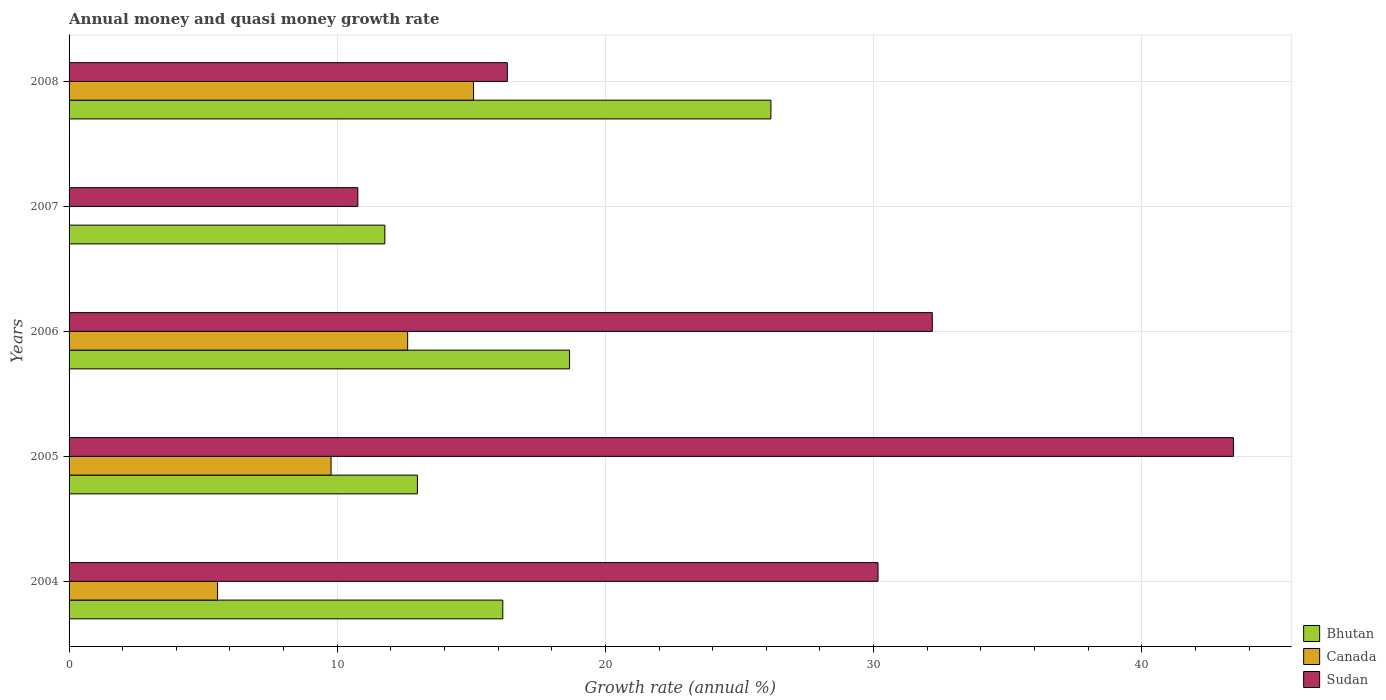How many different coloured bars are there?
Your response must be concise. 3. How many groups of bars are there?
Your answer should be compact. 5. Are the number of bars on each tick of the Y-axis equal?
Provide a succinct answer. No. How many bars are there on the 3rd tick from the top?
Ensure brevity in your answer.  3. In how many cases, is the number of bars for a given year not equal to the number of legend labels?
Your answer should be compact. 1. What is the growth rate in Canada in 2005?
Your answer should be very brief. 9.77. Across all years, what is the maximum growth rate in Sudan?
Your response must be concise. 43.42. Across all years, what is the minimum growth rate in Bhutan?
Your response must be concise. 11.78. What is the total growth rate in Bhutan in the graph?
Provide a short and direct response. 85.77. What is the difference between the growth rate in Bhutan in 2004 and that in 2007?
Provide a short and direct response. 4.4. What is the difference between the growth rate in Bhutan in 2006 and the growth rate in Canada in 2008?
Provide a short and direct response. 3.58. What is the average growth rate in Bhutan per year?
Your answer should be very brief. 17.15. In the year 2004, what is the difference between the growth rate in Sudan and growth rate in Bhutan?
Ensure brevity in your answer.  13.99. In how many years, is the growth rate in Bhutan greater than 32 %?
Keep it short and to the point. 0. What is the ratio of the growth rate in Sudan in 2004 to that in 2008?
Provide a short and direct response. 1.85. Is the growth rate in Sudan in 2005 less than that in 2006?
Provide a succinct answer. No. What is the difference between the highest and the second highest growth rate in Sudan?
Give a very brief answer. 11.23. What is the difference between the highest and the lowest growth rate in Bhutan?
Offer a very short reply. 14.4. In how many years, is the growth rate in Bhutan greater than the average growth rate in Bhutan taken over all years?
Offer a very short reply. 2. Is the sum of the growth rate in Canada in 2004 and 2008 greater than the maximum growth rate in Sudan across all years?
Give a very brief answer. No. Is it the case that in every year, the sum of the growth rate in Sudan and growth rate in Bhutan is greater than the growth rate in Canada?
Make the answer very short. Yes. Are all the bars in the graph horizontal?
Ensure brevity in your answer.  Yes. What is the difference between two consecutive major ticks on the X-axis?
Offer a very short reply. 10. Are the values on the major ticks of X-axis written in scientific E-notation?
Ensure brevity in your answer.  No. How many legend labels are there?
Give a very brief answer. 3. What is the title of the graph?
Your answer should be compact. Annual money and quasi money growth rate. Does "Iraq" appear as one of the legend labels in the graph?
Your answer should be very brief. No. What is the label or title of the X-axis?
Your answer should be compact. Growth rate (annual %). What is the Growth rate (annual %) in Bhutan in 2004?
Your answer should be compact. 16.17. What is the Growth rate (annual %) of Canada in 2004?
Offer a terse response. 5.54. What is the Growth rate (annual %) in Sudan in 2004?
Your answer should be very brief. 30.17. What is the Growth rate (annual %) in Bhutan in 2005?
Provide a short and direct response. 12.99. What is the Growth rate (annual %) in Canada in 2005?
Provide a succinct answer. 9.77. What is the Growth rate (annual %) of Sudan in 2005?
Keep it short and to the point. 43.42. What is the Growth rate (annual %) in Bhutan in 2006?
Offer a terse response. 18.66. What is the Growth rate (annual %) in Canada in 2006?
Provide a short and direct response. 12.63. What is the Growth rate (annual %) in Sudan in 2006?
Give a very brief answer. 32.19. What is the Growth rate (annual %) of Bhutan in 2007?
Your answer should be very brief. 11.78. What is the Growth rate (annual %) in Canada in 2007?
Your answer should be compact. 0. What is the Growth rate (annual %) in Sudan in 2007?
Your answer should be compact. 10.77. What is the Growth rate (annual %) of Bhutan in 2008?
Offer a very short reply. 26.17. What is the Growth rate (annual %) in Canada in 2008?
Ensure brevity in your answer.  15.08. What is the Growth rate (annual %) of Sudan in 2008?
Your answer should be very brief. 16.34. Across all years, what is the maximum Growth rate (annual %) of Bhutan?
Offer a very short reply. 26.17. Across all years, what is the maximum Growth rate (annual %) of Canada?
Your answer should be very brief. 15.08. Across all years, what is the maximum Growth rate (annual %) of Sudan?
Ensure brevity in your answer.  43.42. Across all years, what is the minimum Growth rate (annual %) in Bhutan?
Your answer should be compact. 11.78. Across all years, what is the minimum Growth rate (annual %) of Sudan?
Your answer should be compact. 10.77. What is the total Growth rate (annual %) in Bhutan in the graph?
Offer a terse response. 85.77. What is the total Growth rate (annual %) in Canada in the graph?
Offer a very short reply. 43.02. What is the total Growth rate (annual %) in Sudan in the graph?
Your answer should be compact. 132.88. What is the difference between the Growth rate (annual %) in Bhutan in 2004 and that in 2005?
Your answer should be compact. 3.18. What is the difference between the Growth rate (annual %) of Canada in 2004 and that in 2005?
Your answer should be very brief. -4.23. What is the difference between the Growth rate (annual %) of Sudan in 2004 and that in 2005?
Provide a short and direct response. -13.25. What is the difference between the Growth rate (annual %) of Bhutan in 2004 and that in 2006?
Offer a very short reply. -2.49. What is the difference between the Growth rate (annual %) in Canada in 2004 and that in 2006?
Make the answer very short. -7.09. What is the difference between the Growth rate (annual %) of Sudan in 2004 and that in 2006?
Give a very brief answer. -2.02. What is the difference between the Growth rate (annual %) of Bhutan in 2004 and that in 2007?
Your answer should be very brief. 4.4. What is the difference between the Growth rate (annual %) in Sudan in 2004 and that in 2007?
Make the answer very short. 19.4. What is the difference between the Growth rate (annual %) of Bhutan in 2004 and that in 2008?
Make the answer very short. -10. What is the difference between the Growth rate (annual %) of Canada in 2004 and that in 2008?
Offer a terse response. -9.55. What is the difference between the Growth rate (annual %) in Sudan in 2004 and that in 2008?
Offer a very short reply. 13.82. What is the difference between the Growth rate (annual %) of Bhutan in 2005 and that in 2006?
Ensure brevity in your answer.  -5.67. What is the difference between the Growth rate (annual %) of Canada in 2005 and that in 2006?
Your response must be concise. -2.86. What is the difference between the Growth rate (annual %) of Sudan in 2005 and that in 2006?
Offer a terse response. 11.23. What is the difference between the Growth rate (annual %) of Bhutan in 2005 and that in 2007?
Provide a succinct answer. 1.21. What is the difference between the Growth rate (annual %) of Sudan in 2005 and that in 2007?
Your answer should be compact. 32.65. What is the difference between the Growth rate (annual %) in Bhutan in 2005 and that in 2008?
Offer a terse response. -13.18. What is the difference between the Growth rate (annual %) in Canada in 2005 and that in 2008?
Give a very brief answer. -5.31. What is the difference between the Growth rate (annual %) of Sudan in 2005 and that in 2008?
Offer a very short reply. 27.08. What is the difference between the Growth rate (annual %) in Bhutan in 2006 and that in 2007?
Make the answer very short. 6.89. What is the difference between the Growth rate (annual %) of Sudan in 2006 and that in 2007?
Give a very brief answer. 21.42. What is the difference between the Growth rate (annual %) in Bhutan in 2006 and that in 2008?
Your answer should be compact. -7.51. What is the difference between the Growth rate (annual %) of Canada in 2006 and that in 2008?
Offer a terse response. -2.46. What is the difference between the Growth rate (annual %) of Sudan in 2006 and that in 2008?
Your answer should be compact. 15.85. What is the difference between the Growth rate (annual %) of Bhutan in 2007 and that in 2008?
Keep it short and to the point. -14.4. What is the difference between the Growth rate (annual %) of Sudan in 2007 and that in 2008?
Offer a very short reply. -5.57. What is the difference between the Growth rate (annual %) in Bhutan in 2004 and the Growth rate (annual %) in Canada in 2005?
Provide a succinct answer. 6.4. What is the difference between the Growth rate (annual %) in Bhutan in 2004 and the Growth rate (annual %) in Sudan in 2005?
Provide a succinct answer. -27.24. What is the difference between the Growth rate (annual %) of Canada in 2004 and the Growth rate (annual %) of Sudan in 2005?
Make the answer very short. -37.88. What is the difference between the Growth rate (annual %) in Bhutan in 2004 and the Growth rate (annual %) in Canada in 2006?
Make the answer very short. 3.55. What is the difference between the Growth rate (annual %) of Bhutan in 2004 and the Growth rate (annual %) of Sudan in 2006?
Provide a short and direct response. -16.02. What is the difference between the Growth rate (annual %) of Canada in 2004 and the Growth rate (annual %) of Sudan in 2006?
Your answer should be compact. -26.65. What is the difference between the Growth rate (annual %) in Bhutan in 2004 and the Growth rate (annual %) in Sudan in 2007?
Ensure brevity in your answer.  5.4. What is the difference between the Growth rate (annual %) in Canada in 2004 and the Growth rate (annual %) in Sudan in 2007?
Keep it short and to the point. -5.23. What is the difference between the Growth rate (annual %) in Bhutan in 2004 and the Growth rate (annual %) in Canada in 2008?
Keep it short and to the point. 1.09. What is the difference between the Growth rate (annual %) of Bhutan in 2004 and the Growth rate (annual %) of Sudan in 2008?
Make the answer very short. -0.17. What is the difference between the Growth rate (annual %) in Canada in 2004 and the Growth rate (annual %) in Sudan in 2008?
Provide a succinct answer. -10.8. What is the difference between the Growth rate (annual %) in Bhutan in 2005 and the Growth rate (annual %) in Canada in 2006?
Ensure brevity in your answer.  0.36. What is the difference between the Growth rate (annual %) in Bhutan in 2005 and the Growth rate (annual %) in Sudan in 2006?
Provide a short and direct response. -19.2. What is the difference between the Growth rate (annual %) of Canada in 2005 and the Growth rate (annual %) of Sudan in 2006?
Your answer should be very brief. -22.42. What is the difference between the Growth rate (annual %) in Bhutan in 2005 and the Growth rate (annual %) in Sudan in 2007?
Your response must be concise. 2.22. What is the difference between the Growth rate (annual %) in Canada in 2005 and the Growth rate (annual %) in Sudan in 2007?
Provide a succinct answer. -1. What is the difference between the Growth rate (annual %) of Bhutan in 2005 and the Growth rate (annual %) of Canada in 2008?
Your response must be concise. -2.09. What is the difference between the Growth rate (annual %) of Bhutan in 2005 and the Growth rate (annual %) of Sudan in 2008?
Make the answer very short. -3.35. What is the difference between the Growth rate (annual %) of Canada in 2005 and the Growth rate (annual %) of Sudan in 2008?
Ensure brevity in your answer.  -6.57. What is the difference between the Growth rate (annual %) of Bhutan in 2006 and the Growth rate (annual %) of Sudan in 2007?
Make the answer very short. 7.89. What is the difference between the Growth rate (annual %) of Canada in 2006 and the Growth rate (annual %) of Sudan in 2007?
Make the answer very short. 1.86. What is the difference between the Growth rate (annual %) in Bhutan in 2006 and the Growth rate (annual %) in Canada in 2008?
Offer a terse response. 3.58. What is the difference between the Growth rate (annual %) of Bhutan in 2006 and the Growth rate (annual %) of Sudan in 2008?
Your response must be concise. 2.32. What is the difference between the Growth rate (annual %) in Canada in 2006 and the Growth rate (annual %) in Sudan in 2008?
Your answer should be compact. -3.72. What is the difference between the Growth rate (annual %) in Bhutan in 2007 and the Growth rate (annual %) in Canada in 2008?
Your answer should be very brief. -3.31. What is the difference between the Growth rate (annual %) in Bhutan in 2007 and the Growth rate (annual %) in Sudan in 2008?
Your answer should be very brief. -4.57. What is the average Growth rate (annual %) of Bhutan per year?
Keep it short and to the point. 17.15. What is the average Growth rate (annual %) of Canada per year?
Offer a terse response. 8.6. What is the average Growth rate (annual %) of Sudan per year?
Provide a short and direct response. 26.58. In the year 2004, what is the difference between the Growth rate (annual %) of Bhutan and Growth rate (annual %) of Canada?
Ensure brevity in your answer.  10.64. In the year 2004, what is the difference between the Growth rate (annual %) of Bhutan and Growth rate (annual %) of Sudan?
Ensure brevity in your answer.  -13.99. In the year 2004, what is the difference between the Growth rate (annual %) in Canada and Growth rate (annual %) in Sudan?
Offer a terse response. -24.63. In the year 2005, what is the difference between the Growth rate (annual %) of Bhutan and Growth rate (annual %) of Canada?
Provide a succinct answer. 3.22. In the year 2005, what is the difference between the Growth rate (annual %) in Bhutan and Growth rate (annual %) in Sudan?
Your answer should be compact. -30.43. In the year 2005, what is the difference between the Growth rate (annual %) of Canada and Growth rate (annual %) of Sudan?
Provide a succinct answer. -33.65. In the year 2006, what is the difference between the Growth rate (annual %) in Bhutan and Growth rate (annual %) in Canada?
Offer a very short reply. 6.04. In the year 2006, what is the difference between the Growth rate (annual %) in Bhutan and Growth rate (annual %) in Sudan?
Provide a short and direct response. -13.53. In the year 2006, what is the difference between the Growth rate (annual %) of Canada and Growth rate (annual %) of Sudan?
Ensure brevity in your answer.  -19.56. In the year 2007, what is the difference between the Growth rate (annual %) in Bhutan and Growth rate (annual %) in Sudan?
Offer a very short reply. 1.01. In the year 2008, what is the difference between the Growth rate (annual %) in Bhutan and Growth rate (annual %) in Canada?
Offer a terse response. 11.09. In the year 2008, what is the difference between the Growth rate (annual %) of Bhutan and Growth rate (annual %) of Sudan?
Make the answer very short. 9.83. In the year 2008, what is the difference between the Growth rate (annual %) of Canada and Growth rate (annual %) of Sudan?
Offer a very short reply. -1.26. What is the ratio of the Growth rate (annual %) in Bhutan in 2004 to that in 2005?
Make the answer very short. 1.25. What is the ratio of the Growth rate (annual %) in Canada in 2004 to that in 2005?
Your response must be concise. 0.57. What is the ratio of the Growth rate (annual %) of Sudan in 2004 to that in 2005?
Ensure brevity in your answer.  0.69. What is the ratio of the Growth rate (annual %) of Bhutan in 2004 to that in 2006?
Offer a terse response. 0.87. What is the ratio of the Growth rate (annual %) of Canada in 2004 to that in 2006?
Provide a short and direct response. 0.44. What is the ratio of the Growth rate (annual %) of Sudan in 2004 to that in 2006?
Make the answer very short. 0.94. What is the ratio of the Growth rate (annual %) of Bhutan in 2004 to that in 2007?
Keep it short and to the point. 1.37. What is the ratio of the Growth rate (annual %) of Sudan in 2004 to that in 2007?
Your answer should be very brief. 2.8. What is the ratio of the Growth rate (annual %) in Bhutan in 2004 to that in 2008?
Provide a succinct answer. 0.62. What is the ratio of the Growth rate (annual %) in Canada in 2004 to that in 2008?
Ensure brevity in your answer.  0.37. What is the ratio of the Growth rate (annual %) in Sudan in 2004 to that in 2008?
Your answer should be very brief. 1.85. What is the ratio of the Growth rate (annual %) in Bhutan in 2005 to that in 2006?
Give a very brief answer. 0.7. What is the ratio of the Growth rate (annual %) of Canada in 2005 to that in 2006?
Make the answer very short. 0.77. What is the ratio of the Growth rate (annual %) of Sudan in 2005 to that in 2006?
Make the answer very short. 1.35. What is the ratio of the Growth rate (annual %) of Bhutan in 2005 to that in 2007?
Your response must be concise. 1.1. What is the ratio of the Growth rate (annual %) in Sudan in 2005 to that in 2007?
Your answer should be compact. 4.03. What is the ratio of the Growth rate (annual %) in Bhutan in 2005 to that in 2008?
Provide a succinct answer. 0.5. What is the ratio of the Growth rate (annual %) in Canada in 2005 to that in 2008?
Your answer should be compact. 0.65. What is the ratio of the Growth rate (annual %) of Sudan in 2005 to that in 2008?
Offer a very short reply. 2.66. What is the ratio of the Growth rate (annual %) of Bhutan in 2006 to that in 2007?
Your response must be concise. 1.58. What is the ratio of the Growth rate (annual %) of Sudan in 2006 to that in 2007?
Offer a very short reply. 2.99. What is the ratio of the Growth rate (annual %) in Bhutan in 2006 to that in 2008?
Offer a very short reply. 0.71. What is the ratio of the Growth rate (annual %) in Canada in 2006 to that in 2008?
Ensure brevity in your answer.  0.84. What is the ratio of the Growth rate (annual %) of Sudan in 2006 to that in 2008?
Your answer should be very brief. 1.97. What is the ratio of the Growth rate (annual %) in Bhutan in 2007 to that in 2008?
Keep it short and to the point. 0.45. What is the ratio of the Growth rate (annual %) in Sudan in 2007 to that in 2008?
Offer a terse response. 0.66. What is the difference between the highest and the second highest Growth rate (annual %) of Bhutan?
Ensure brevity in your answer.  7.51. What is the difference between the highest and the second highest Growth rate (annual %) of Canada?
Offer a very short reply. 2.46. What is the difference between the highest and the second highest Growth rate (annual %) of Sudan?
Offer a very short reply. 11.23. What is the difference between the highest and the lowest Growth rate (annual %) of Bhutan?
Ensure brevity in your answer.  14.4. What is the difference between the highest and the lowest Growth rate (annual %) in Canada?
Provide a succinct answer. 15.08. What is the difference between the highest and the lowest Growth rate (annual %) of Sudan?
Give a very brief answer. 32.65. 